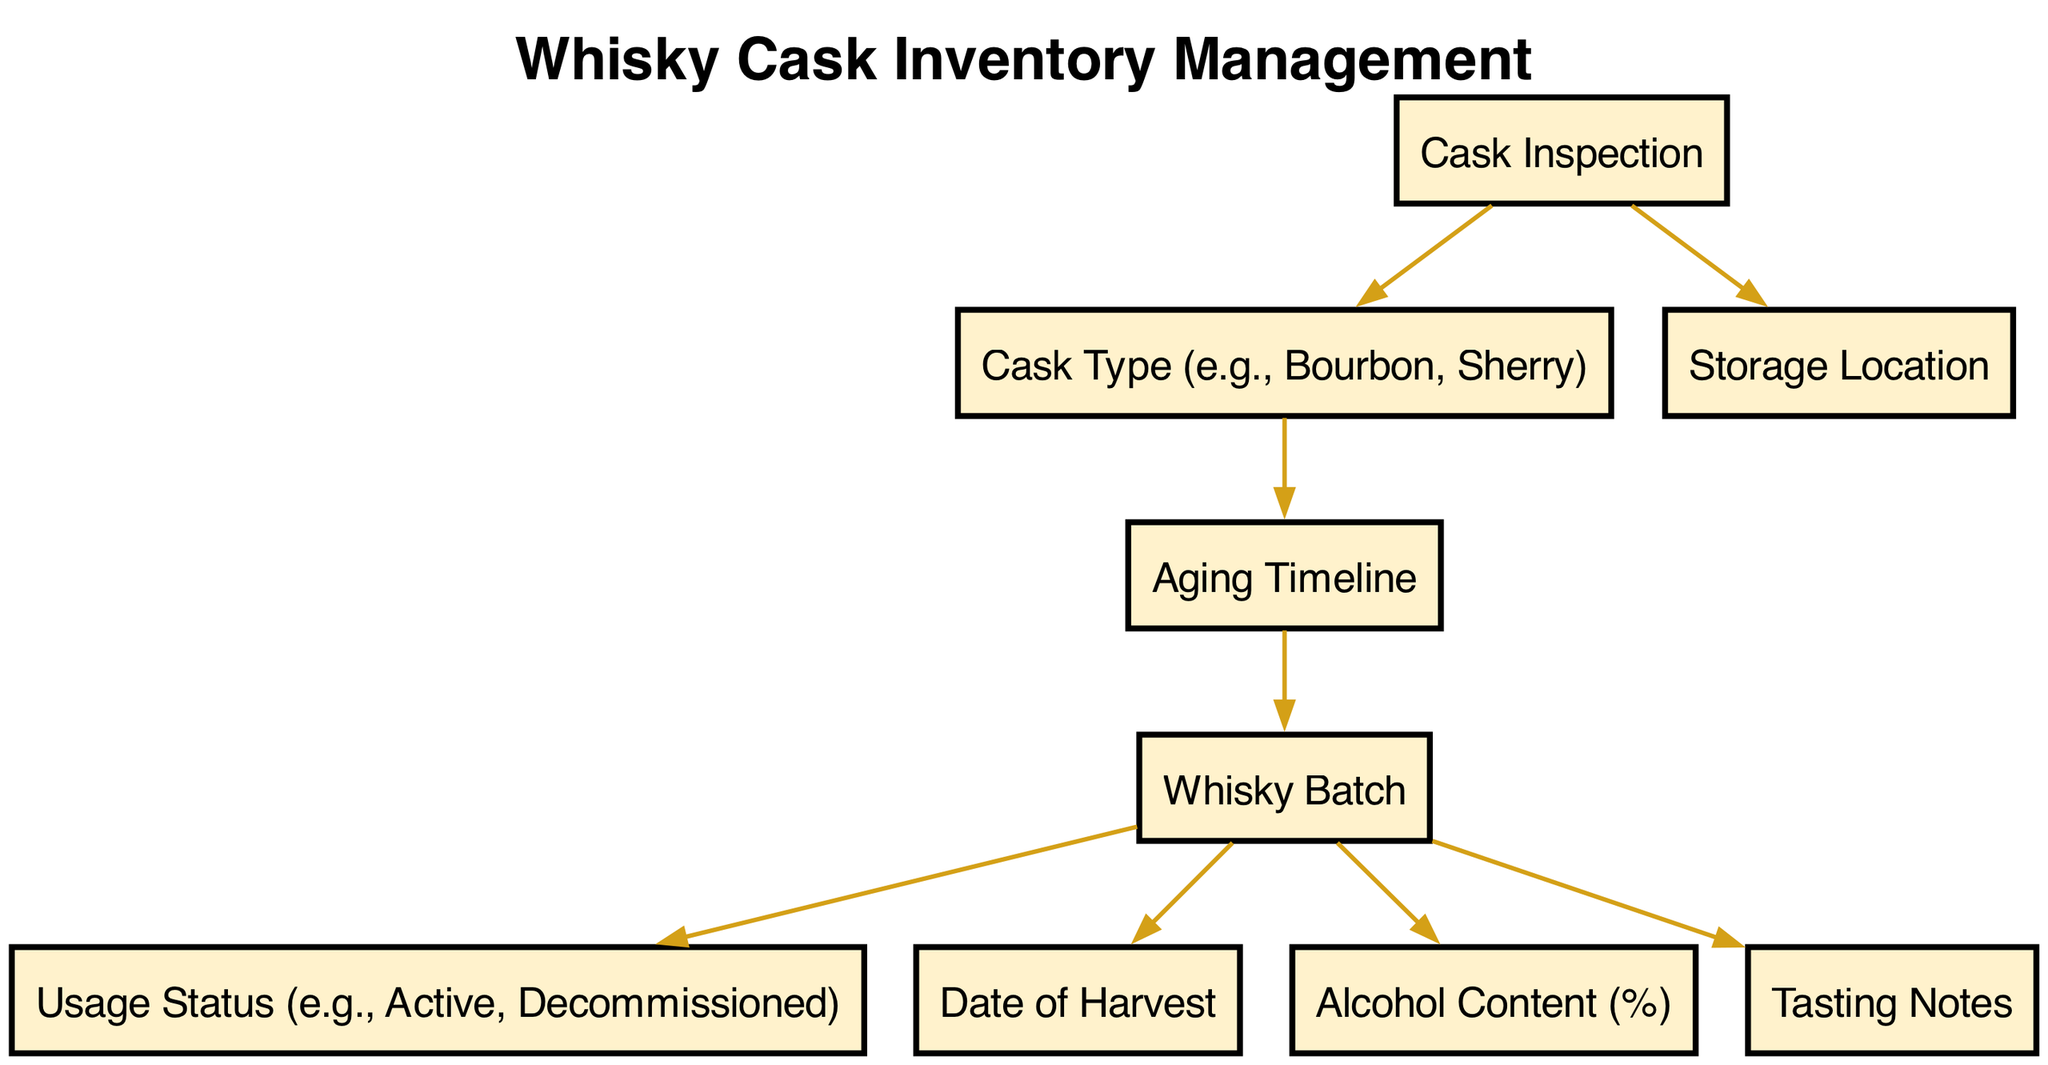What is the starting point of the diagram? The starting point is the "Cask Inspection" node, which is the initial step in the whisky cask management process, indicating where inspections occur before other processes take place.
Answer: Cask Inspection How many nodes are in the diagram? By counting all unique nodes defined in the data, we find there are a total of nine nodes, each representing a different aspect of whisky cask management.
Answer: Nine What relationship exists between "Cask Type" and "Aging Timeline"? The "Cask Type" node points to the "Aging Timeline" node, indicating that the type of cask used influences how long the whisky should be aged.
Answer: Cask Type influences Aging Timeline What follows "Aging Timeline" in the process? The next node in the process after "Aging Timeline" is "Whisky Batch," showing that after determining the aging timeline, a specific batch of whisky is produced.
Answer: Whisky Batch Which nodes are directly connected to "Whisky Batch"? The nodes that are directly connected to "Whisky Batch" are "Usage Status," "Date of Harvest," "Alcohol Content," and "Tasting Notes," indicating various attributes associated with each whisky batch.
Answer: Usage Status, Date of Harvest, Alcohol Content, Tasting Notes What indicates the status of a whisky batch? The connection from "Whisky Batch" to "Usage Status" indicates that each whisky batch has an associated status, showing whether it is active or decommissioned.
Answer: Usage Status If a cask type is Bourbon, which node must follow? If the cask type is Bourbon, it leads to the "Aging Timeline" node, which focuses on the specific aging duration required for that type of cask.
Answer: Aging Timeline What does the "Date of Harvest" node represent? The "Date of Harvest" node represents the specific date when the ingredients for the whisky batch were harvested, crucial for tracking production timelines.
Answer: Date of Harvest How does "Cask Inspection" affect storage? "Cask Inspection" impacts "Storage Location" by determining where casks should be stored based on their inspection results, ensuring proper conditions are met.
Answer: Cask Inspection affects Storage Location 